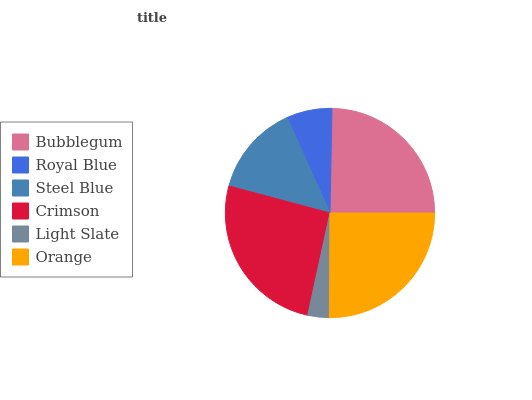Is Light Slate the minimum?
Answer yes or no. Yes. Is Crimson the maximum?
Answer yes or no. Yes. Is Royal Blue the minimum?
Answer yes or no. No. Is Royal Blue the maximum?
Answer yes or no. No. Is Bubblegum greater than Royal Blue?
Answer yes or no. Yes. Is Royal Blue less than Bubblegum?
Answer yes or no. Yes. Is Royal Blue greater than Bubblegum?
Answer yes or no. No. Is Bubblegum less than Royal Blue?
Answer yes or no. No. Is Bubblegum the high median?
Answer yes or no. Yes. Is Steel Blue the low median?
Answer yes or no. Yes. Is Light Slate the high median?
Answer yes or no. No. Is Royal Blue the low median?
Answer yes or no. No. 